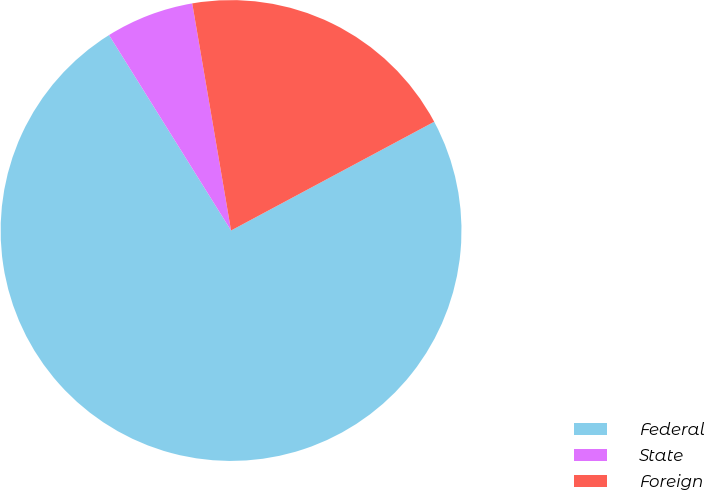<chart> <loc_0><loc_0><loc_500><loc_500><pie_chart><fcel>Federal<fcel>State<fcel>Foreign<nl><fcel>73.94%<fcel>6.19%<fcel>19.87%<nl></chart> 